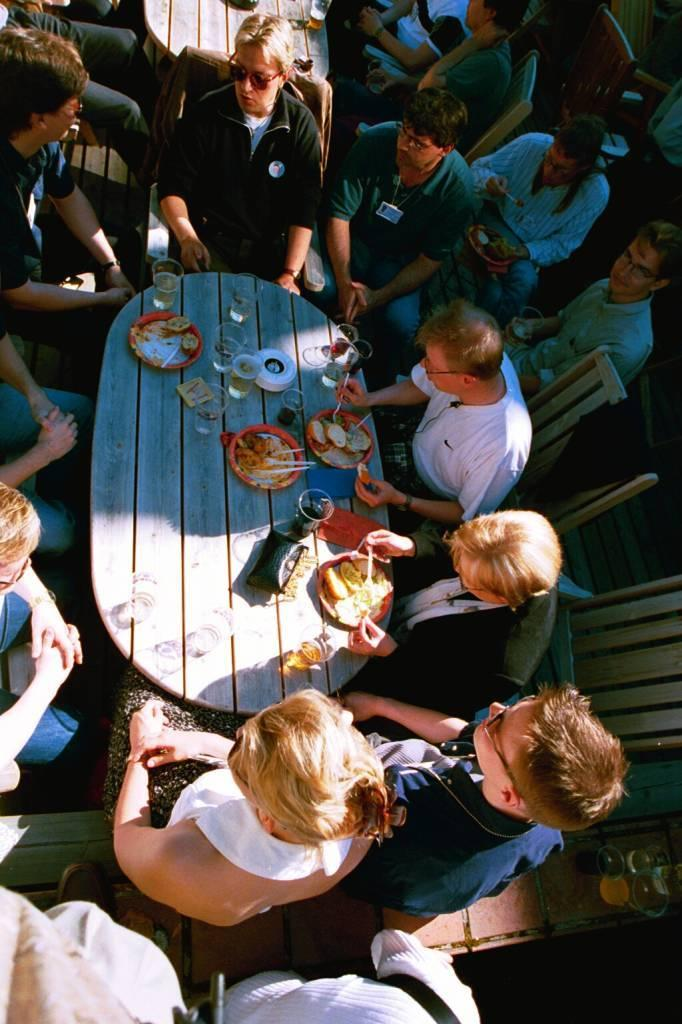What are the people in the image doing? The people in the image are sitting on chairs. What is located between the chairs? There is a table in between the chairs. What are the people eating in the image? The people have food items on plates. What else can be seen in the image besides the food? There are drinks present. From which angle is the image taken? The image is a top view. What type of birds can be seen flying over the table in the image? There are no birds visible in the image; it is a top view of people sitting at a table with food and drinks. 